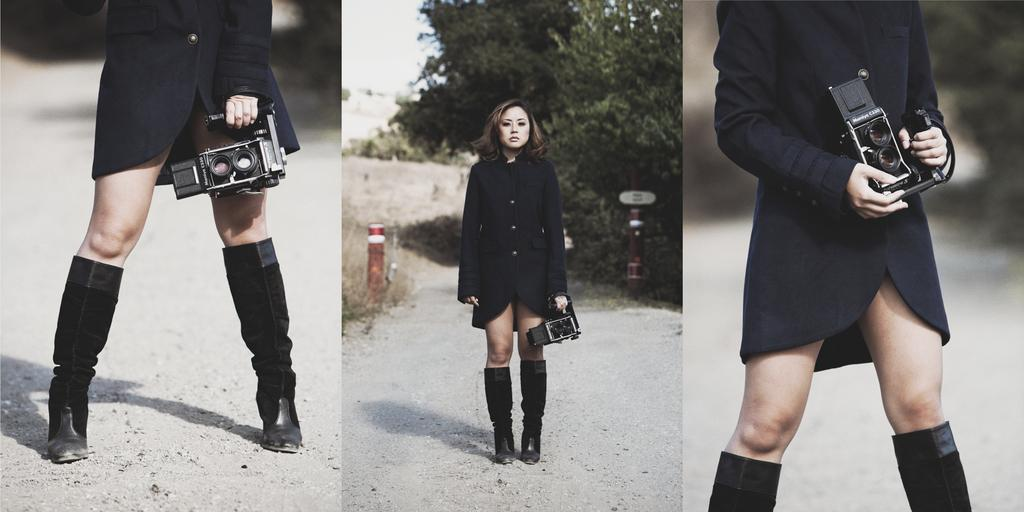How many images are included in the collage? The collage consists of three images. What is the woman doing in each image? In each image, a woman is holding a camera in her hands. Can you describe the middle image in the collage? In the middle image, there is a tree. What type of clocks can be seen in the image? There are no clocks present in the image. What is the woman reading in the image? There is no reading material visible in the image; the woman is holding a camera. 